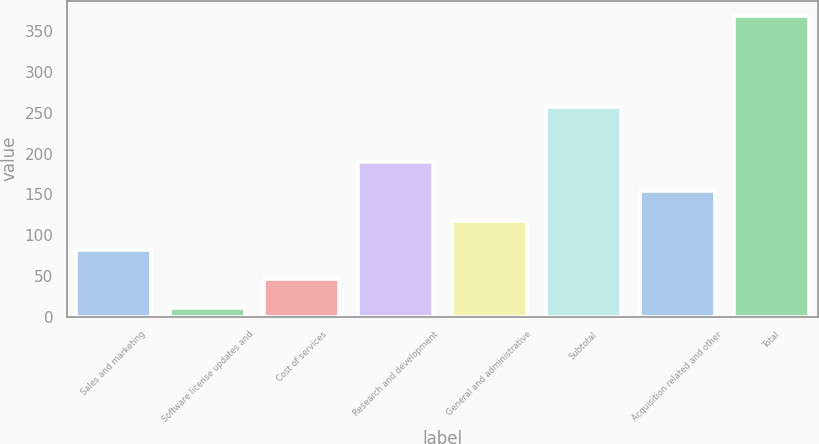<chart> <loc_0><loc_0><loc_500><loc_500><bar_chart><fcel>Sales and marketing<fcel>Software license updates and<fcel>Cost of services<fcel>Research and development<fcel>General and administrative<fcel>Subtotal<fcel>Acquisition related and other<fcel>Total<nl><fcel>81.8<fcel>10<fcel>45.9<fcel>189.5<fcel>117.7<fcel>257<fcel>153.6<fcel>369<nl></chart> 